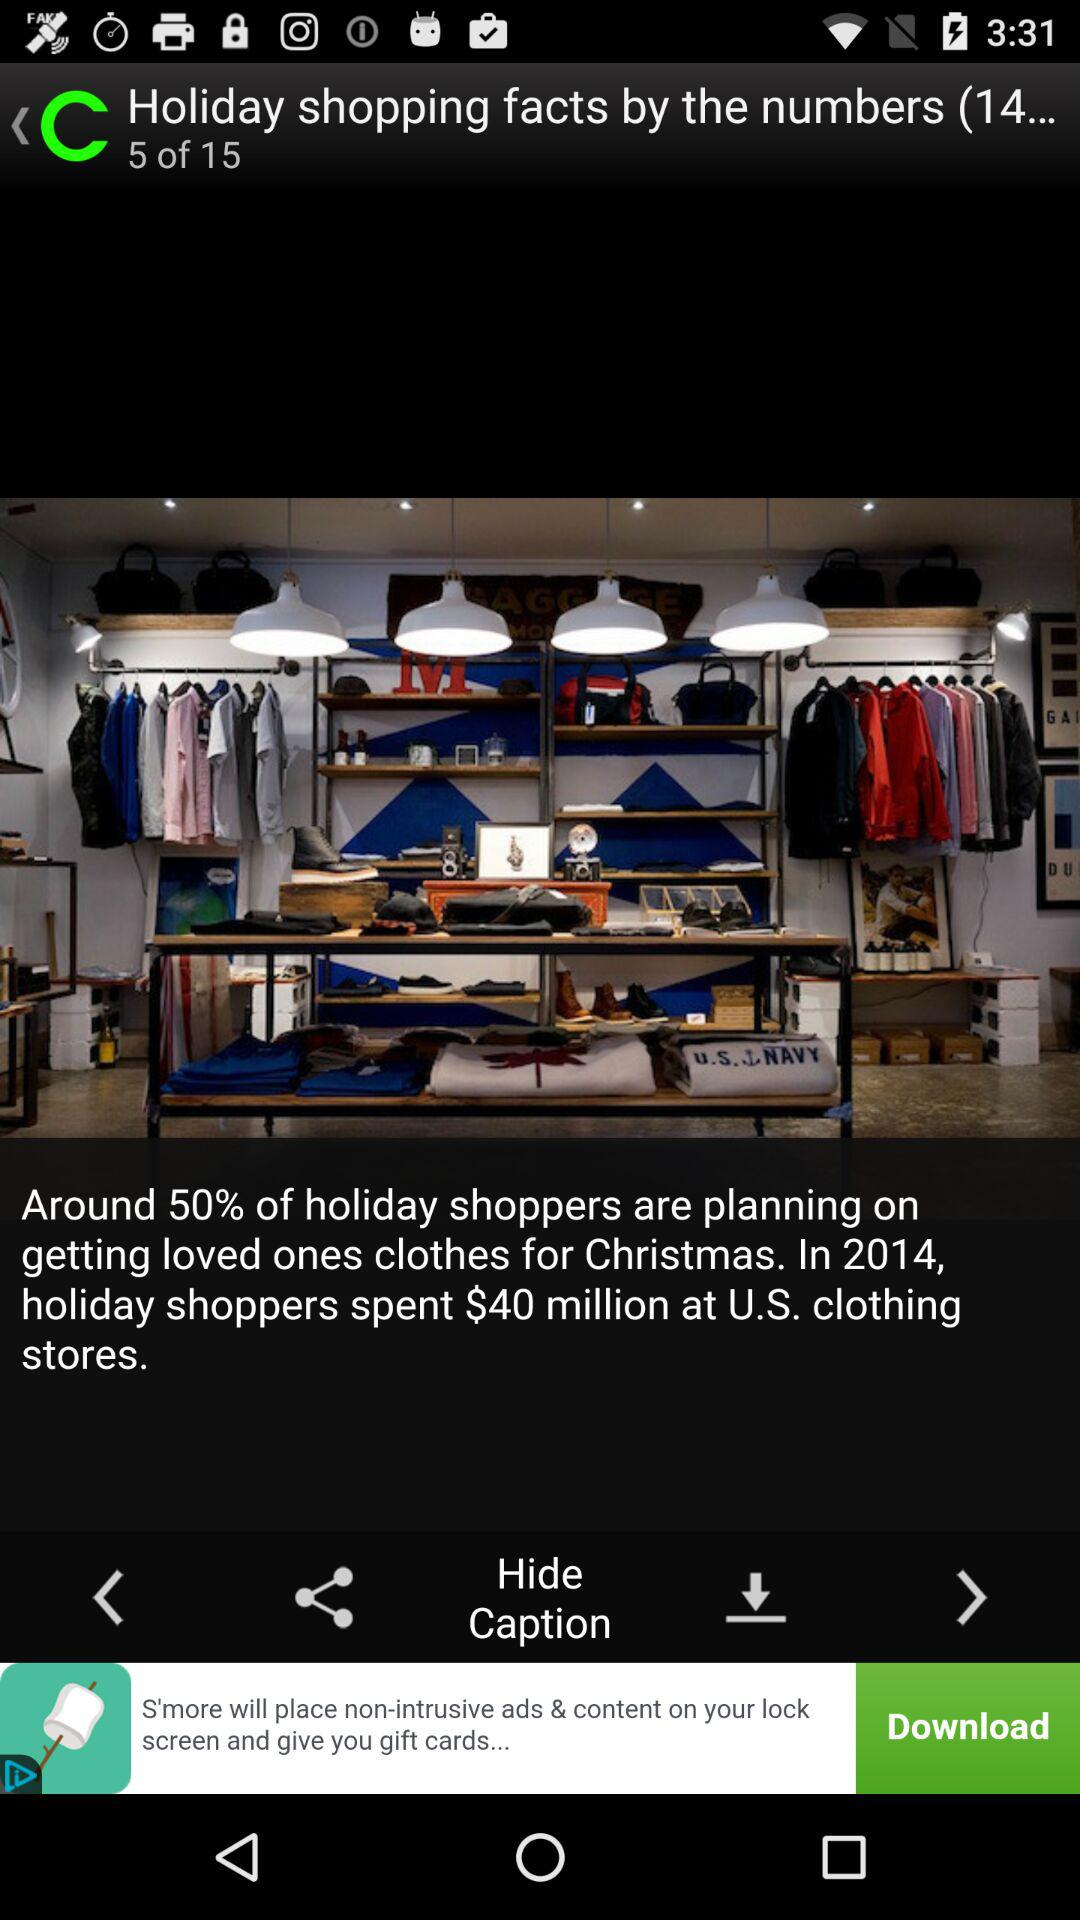On which image is the person currently located? The person is currently located on image 5. 